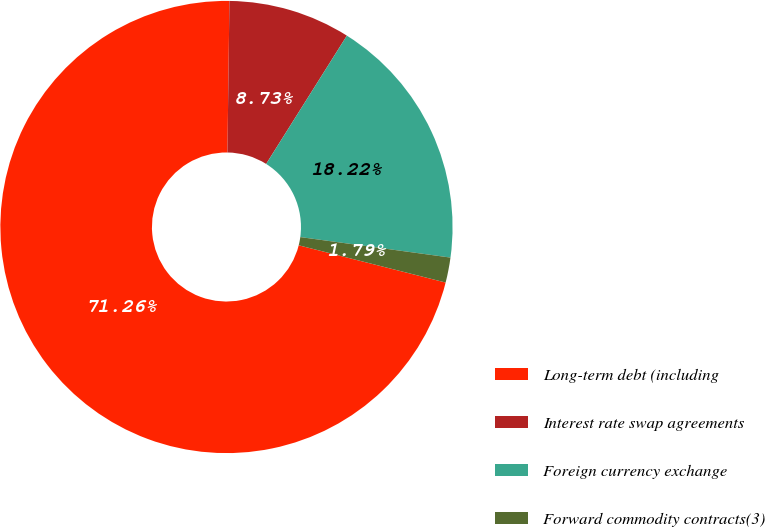Convert chart. <chart><loc_0><loc_0><loc_500><loc_500><pie_chart><fcel>Long-term debt (including<fcel>Interest rate swap agreements<fcel>Foreign currency exchange<fcel>Forward commodity contracts(3)<nl><fcel>71.26%<fcel>8.73%<fcel>18.22%<fcel>1.79%<nl></chart> 